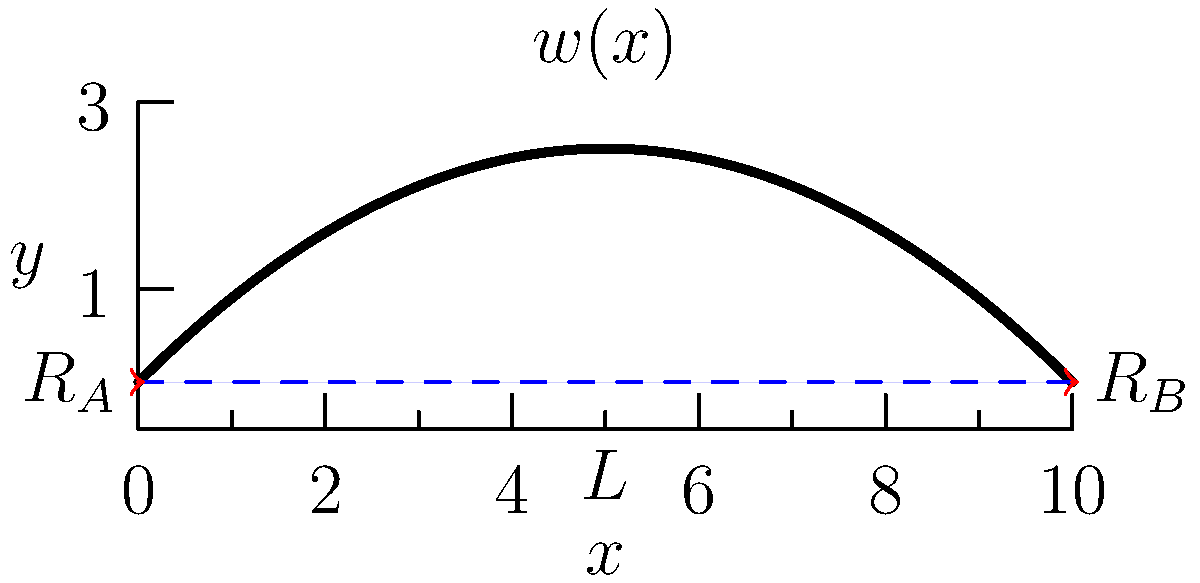A railroad bridge spanning 10 meters is subjected to heavy snow loads during a severe winter storm. The snow load can be modeled as a distributed load $w(x) = 5000(1 - \frac{x}{L})$ N/m, where $x$ is the distance from the left support and $L$ is the total length of the bridge. Calculate the maximum bending moment in the bridge and determine its location. To solve this problem, we'll follow these steps:

1) First, we need to determine the reactions at the supports. Due to symmetry, we can conclude that $R_A = R_B = \frac{1}{2}\int_0^L w(x)dx$.

2) Calculate the total load:
   $$\int_0^L w(x)dx = \int_0^{10} 5000(1 - \frac{x}{10})dx = 5000[x - \frac{x^2}{20}]_0^{10} = 25000 \text{ N}$$

3) Therefore, $R_A = R_B = 12500 \text{ N}$

4) The shear force at any point $x$ is given by:
   $$V(x) = R_A - \int_0^x w(x)dx = 12500 - 5000[x - \frac{x^2}{20}]_0^x = 12500 - 5000x + 250x^2$$

5) The bending moment at any point $x$ is the integral of the shear force:
   $$M(x) = \int V(x)dx = 12500x - 2500x^2 + \frac{250}{3}x^3 + C$$

6) At $x = 0$, $M(0) = 0$, so $C = 0$

7) To find the maximum bending moment, we differentiate $M(x)$ and set it to zero:
   $$\frac{dM}{dx} = 12500 - 5000x + 250x^2 = 0$$

8) Solving this quadratic equation:
   $$x = \frac{5000 \pm \sqrt{5000^2 - 4(250)(12500)}}{2(250)} = 5 \text{ m}$$

9) The maximum bending moment occurs at $x = 5 \text{ m}$ (midspan)

10) Calculate the maximum bending moment:
    $$M_{max} = M(5) = 12500(5) - 2500(5^2) + \frac{250}{3}(5^3) = 15625 \text{ N⋅m}$$
Answer: 15625 N⋅m at midspan (5 m) 